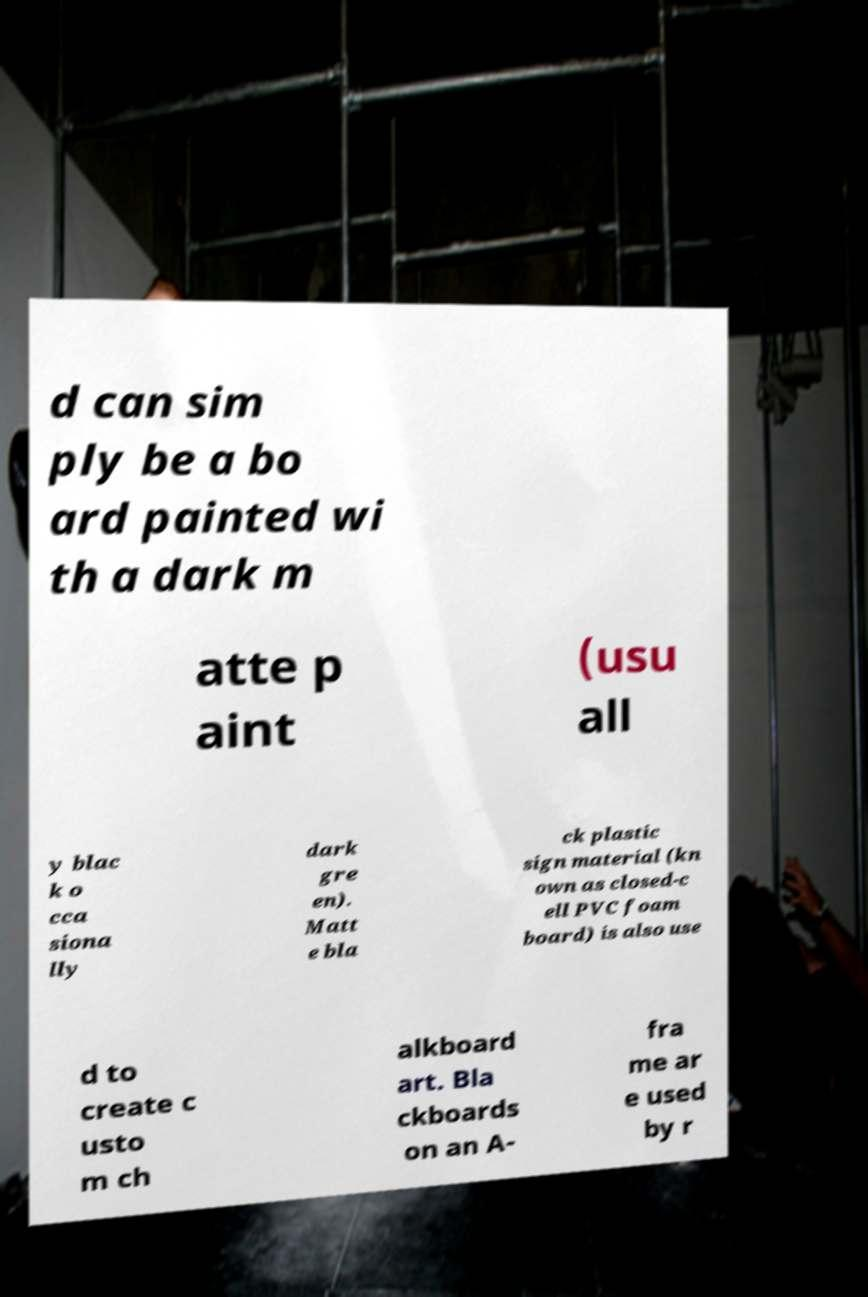What messages or text are displayed in this image? I need them in a readable, typed format. d can sim ply be a bo ard painted wi th a dark m atte p aint (usu all y blac k o cca siona lly dark gre en). Matt e bla ck plastic sign material (kn own as closed-c ell PVC foam board) is also use d to create c usto m ch alkboard art. Bla ckboards on an A- fra me ar e used by r 